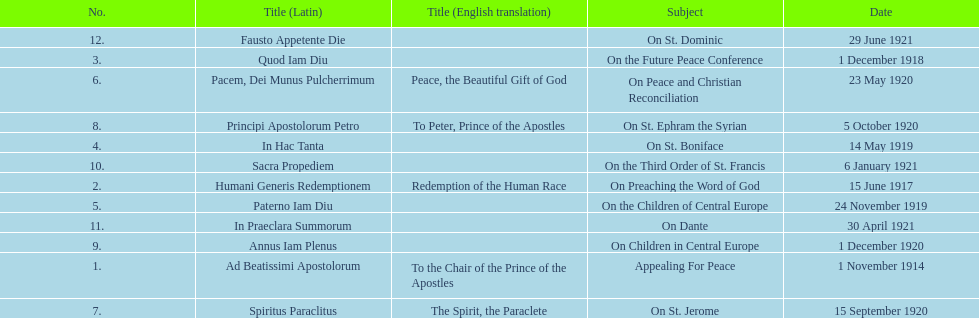What is the total number of encyclicals to take place in december? 2. 